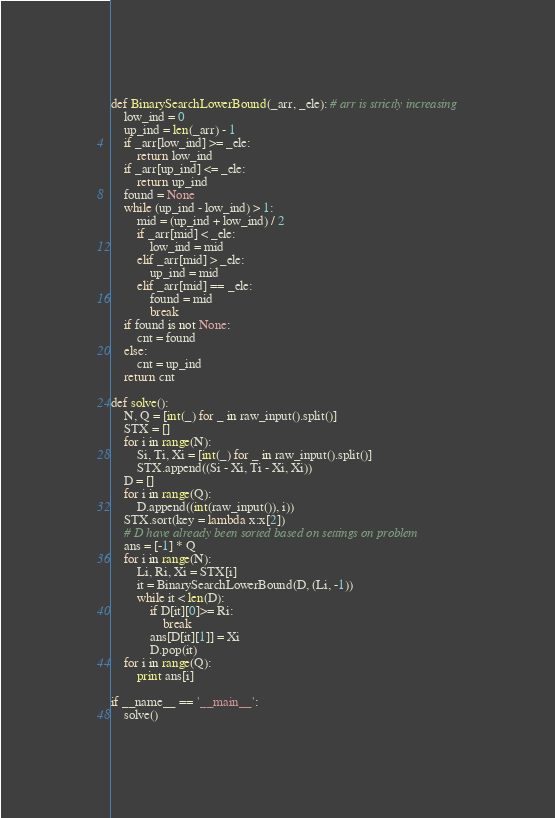Convert code to text. <code><loc_0><loc_0><loc_500><loc_500><_Python_>def BinarySearchLowerBound(_arr, _ele): # arr is strictly increasing
    low_ind = 0
    up_ind = len(_arr) - 1
    if _arr[low_ind] >= _ele:
        return low_ind
    if _arr[up_ind] <= _ele:
        return up_ind
    found = None
    while (up_ind - low_ind) > 1:
        mid = (up_ind + low_ind) / 2
        if _arr[mid] < _ele:
            low_ind = mid
        elif _arr[mid] > _ele:
            up_ind = mid
        elif _arr[mid] == _ele:
            found = mid
            break
    if found is not None:
        cnt = found
    else:
        cnt = up_ind
    return cnt

def solve():
    N, Q = [int(_) for _ in raw_input().split()]
    STX = []
    for i in range(N):
        Si, Ti, Xi = [int(_) for _ in raw_input().split()]
        STX.append((Si - Xi, Ti - Xi, Xi))
    D = []
    for i in range(Q):
        D.append((int(raw_input()), i))
    STX.sort(key = lambda x:x[2])
    # D have already been sorted based on settings on problem
    ans = [-1] * Q
    for i in range(N):
        Li, Ri, Xi = STX[i]
        it = BinarySearchLowerBound(D, (Li, -1))
        while it < len(D):
            if D[it][0]>= Ri:
                break
            ans[D[it][1]] = Xi
            D.pop(it)
    for i in range(Q):
        print ans[i]

if __name__ == '__main__':
    solve()
</code> 